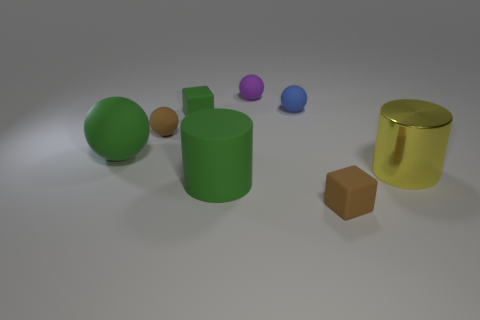There is a small matte ball that is in front of the small green thing; is its color the same as the tiny rubber object that is in front of the large green ball?
Ensure brevity in your answer.  Yes. How many things are either tiny purple things or blue cubes?
Keep it short and to the point. 1. What number of other small objects have the same material as the blue thing?
Your answer should be compact. 4. Is the number of yellow objects less than the number of tiny purple metal cylinders?
Provide a succinct answer. No. Is the large green thing behind the big yellow cylinder made of the same material as the blue object?
Make the answer very short. Yes. What number of spheres are brown objects or tiny purple things?
Make the answer very short. 2. What shape is the object that is both in front of the large metal object and right of the blue matte thing?
Your answer should be very brief. Cube. There is a block behind the rubber ball in front of the small brown thing that is behind the yellow shiny cylinder; what is its color?
Offer a very short reply. Green. Are there fewer small blue rubber balls in front of the brown rubber block than objects?
Your answer should be very brief. Yes. Does the large rubber thing that is behind the yellow shiny cylinder have the same shape as the tiny brown object on the right side of the tiny purple rubber object?
Your response must be concise. No. 